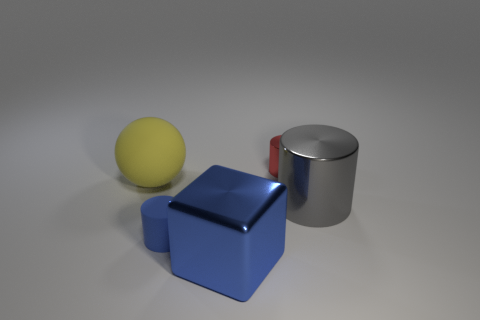What number of large yellow rubber objects are behind the cylinder left of the big thing that is in front of the tiny blue matte object?
Your answer should be very brief. 1. What number of tiny things are blue cubes or green metal cubes?
Provide a short and direct response. 0. Does the tiny object behind the blue cylinder have the same material as the block?
Provide a short and direct response. Yes. What is the material of the object that is left of the small cylinder in front of the small cylinder that is on the right side of the tiny blue object?
Keep it short and to the point. Rubber. How many shiny objects are small blue cylinders or large yellow spheres?
Provide a succinct answer. 0. Is there a blue metallic thing?
Offer a very short reply. Yes. The large object that is in front of the large thing to the right of the large blue cube is what color?
Offer a terse response. Blue. How many other things are there of the same color as the sphere?
Offer a terse response. 0. What number of things are tiny blue rubber objects or metallic objects left of the large gray metal object?
Your response must be concise. 3. The thing behind the yellow object is what color?
Your answer should be very brief. Red. 